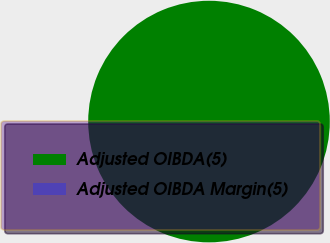<chart> <loc_0><loc_0><loc_500><loc_500><pie_chart><fcel>Adjusted OIBDA(5)<fcel>Adjusted OIBDA Margin(5)<nl><fcel>100.0%<fcel>0.0%<nl></chart> 